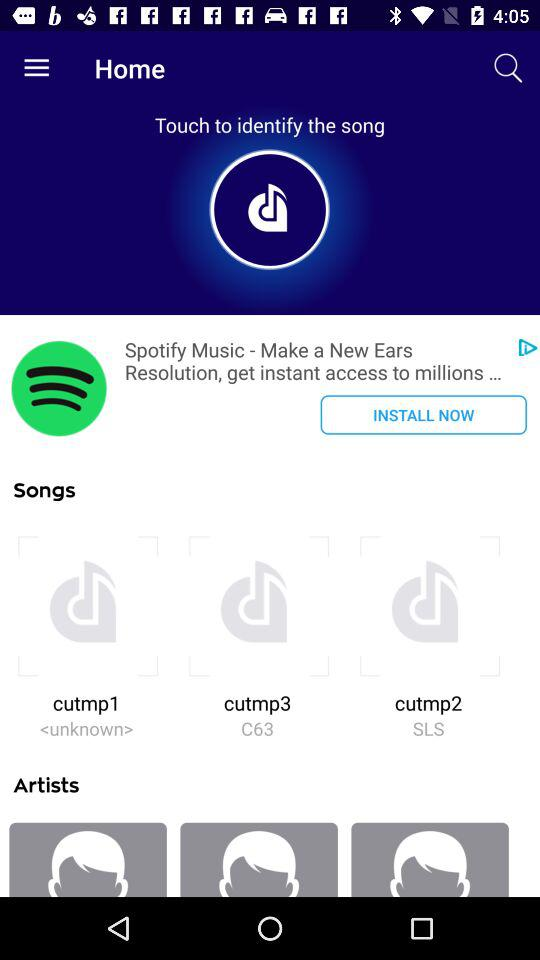What is the application name? It is Spotify Music. 